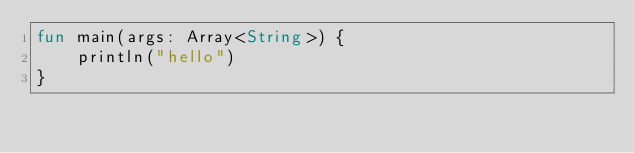<code> <loc_0><loc_0><loc_500><loc_500><_Kotlin_>fun main(args: Array<String>) {
    println("hello")
}
</code> 